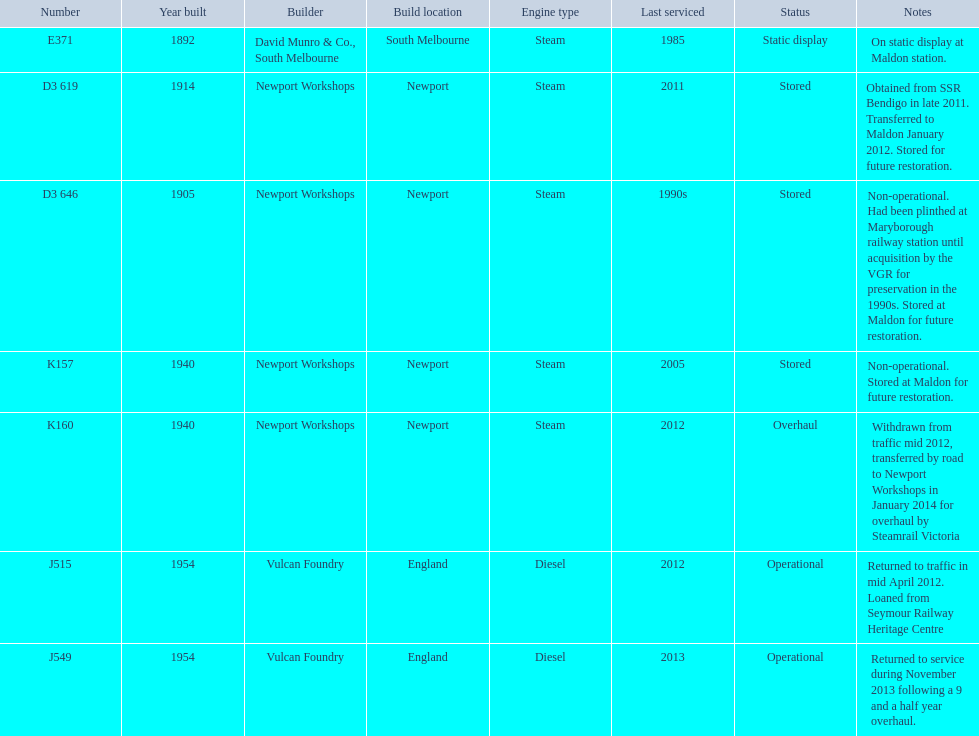Which are the only trains still in service? J515, J549. Can you give me this table as a dict? {'header': ['Number', 'Year built', 'Builder', 'Build location', 'Engine type', 'Last serviced', 'Status', 'Notes'], 'rows': [['E371', '1892', 'David Munro & Co., South Melbourne', 'South Melbourne', 'Steam', '1985', 'Static display', 'On static display at Maldon station.'], ['D3 619', '1914', 'Newport Workshops', 'Newport', 'Steam', '2011', 'Stored', 'Obtained from SSR Bendigo in late 2011. Transferred to Maldon January 2012. Stored for future restoration.'], ['D3 646', '1905', 'Newport Workshops', 'Newport', 'Steam', '1990s', 'Stored', 'Non-operational. Had been plinthed at Maryborough railway station until acquisition by the VGR for preservation in the 1990s. Stored at Maldon for future restoration.'], ['K157', '1940', 'Newport Workshops', 'Newport', 'Steam', '2005', 'Stored', 'Non-operational. Stored at Maldon for future restoration.'], ['K160', '1940', 'Newport Workshops', 'Newport', 'Steam', '2012', 'Overhaul', 'Withdrawn from traffic mid 2012, transferred by road to Newport Workshops in January 2014 for overhaul by Steamrail Victoria'], ['J515', '1954', 'Vulcan Foundry', 'England', 'Diesel', '2012', 'Operational', 'Returned to traffic in mid April 2012. Loaned from Seymour Railway Heritage Centre'], ['J549', '1954', 'Vulcan Foundry', 'England', 'Diesel', '2013', 'Operational', 'Returned to service during November 2013 following a 9 and a half year overhaul.']]} 